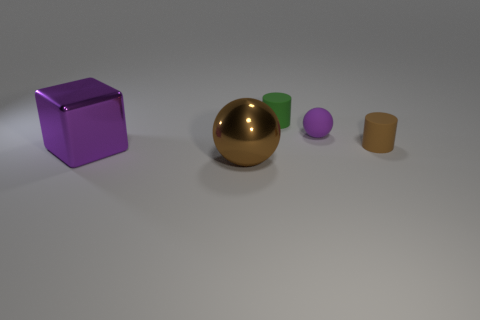What material is the purple object that is right of the large thing that is behind the brown ball made of?
Provide a succinct answer. Rubber. There is another tiny object that is the same shape as the brown matte object; what is its material?
Provide a succinct answer. Rubber. Are there any matte things?
Offer a terse response. Yes. What is the shape of the purple object that is made of the same material as the small brown cylinder?
Make the answer very short. Sphere. There is a ball behind the big brown sphere; what is its material?
Make the answer very short. Rubber. There is a ball that is behind the tiny brown object; does it have the same color as the shiny cube?
Make the answer very short. Yes. How big is the cylinder that is behind the purple object that is behind the big purple object?
Provide a short and direct response. Small. Is the number of small objects to the left of the tiny sphere greater than the number of tiny green metallic objects?
Offer a very short reply. Yes. Does the purple object that is to the right of the purple cube have the same size as the big brown metal sphere?
Keep it short and to the point. No. There is a object that is both to the right of the brown shiny sphere and in front of the tiny purple rubber thing; what is its color?
Your answer should be compact. Brown. 